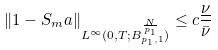<formula> <loc_0><loc_0><loc_500><loc_500>\| 1 - S _ { m } a \| _ { L ^ { \infty } ( 0 , T ; B ^ { \frac { N } { p _ { 1 } } } _ { p _ { 1 } , 1 } ) } \leq c \frac { \underline { \nu } } { \bar { \nu } }</formula> 